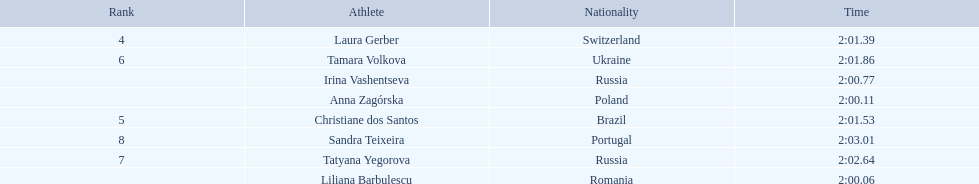How many runners finished with their time below 2:01? 3. 